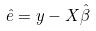Convert formula to latex. <formula><loc_0><loc_0><loc_500><loc_500>\hat { e } = y - X \hat { \beta }</formula> 